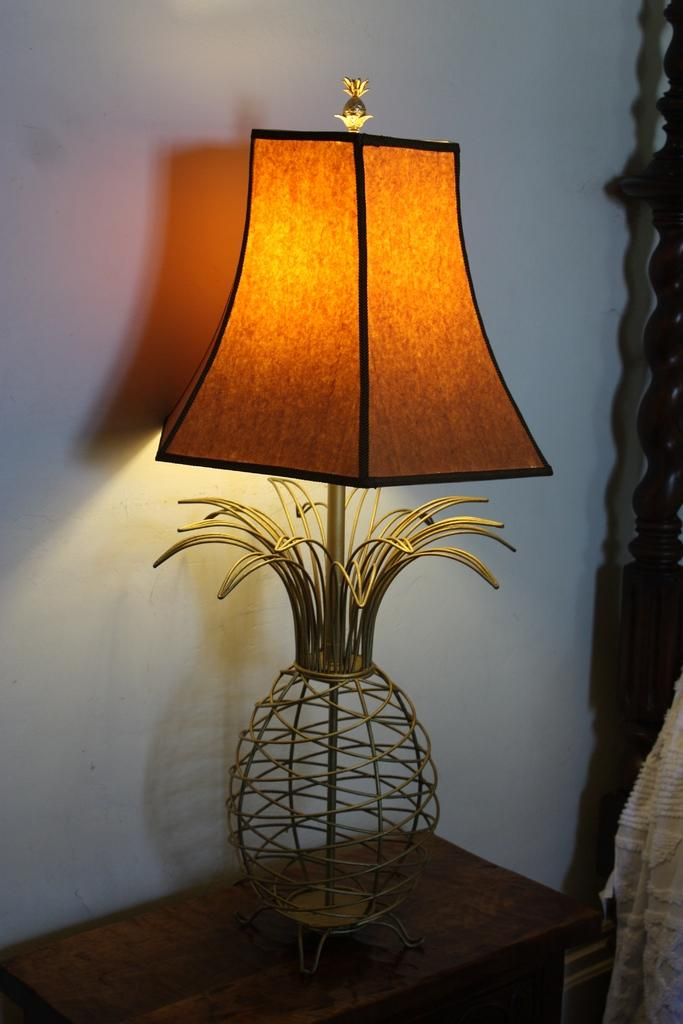What object is located on the table in the foreground of the image? There is a lamp on a table in the foreground of the image. What can be seen on the right side of the image? There is a cloth and a coat on the right side of the image. What is visible in the background of the image? There is a wall in the background of the image. How does the zephyr affect the cloth on the right side of the image? There is no zephyr present in the image, so its effect on the cloth cannot be determined. What type of thrill can be experienced by the coat on the right side of the image? The coat is an inanimate object and cannot experience thrill, so this question is not applicable to the image. 